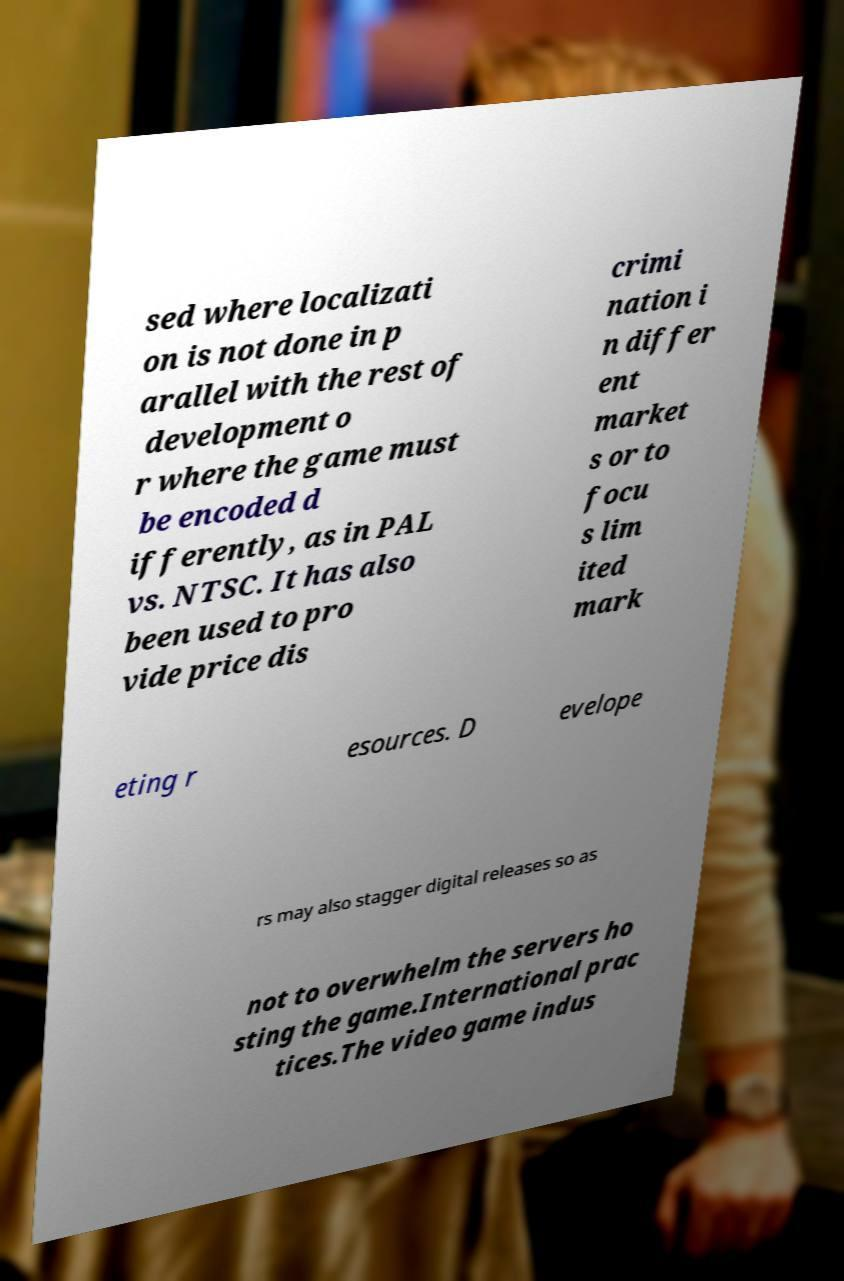Can you accurately transcribe the text from the provided image for me? sed where localizati on is not done in p arallel with the rest of development o r where the game must be encoded d ifferently, as in PAL vs. NTSC. It has also been used to pro vide price dis crimi nation i n differ ent market s or to focu s lim ited mark eting r esources. D evelope rs may also stagger digital releases so as not to overwhelm the servers ho sting the game.International prac tices.The video game indus 